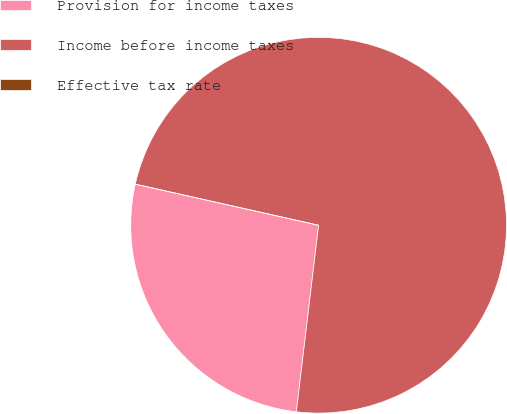Convert chart to OTSL. <chart><loc_0><loc_0><loc_500><loc_500><pie_chart><fcel>Provision for income taxes<fcel>Income before income taxes<fcel>Effective tax rate<nl><fcel>26.62%<fcel>73.38%<fcel>0.0%<nl></chart> 